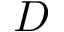Convert formula to latex. <formula><loc_0><loc_0><loc_500><loc_500>D</formula> 